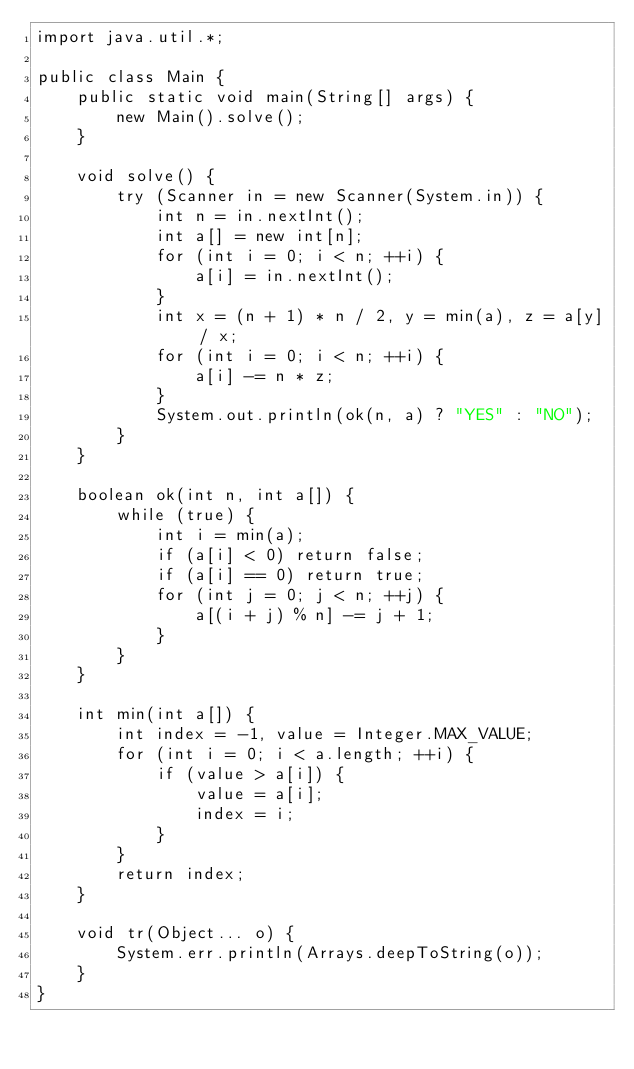<code> <loc_0><loc_0><loc_500><loc_500><_Java_>import java.util.*;

public class Main {
    public static void main(String[] args) {
        new Main().solve();
    }

    void solve() {
        try (Scanner in = new Scanner(System.in)) {
            int n = in.nextInt();
            int a[] = new int[n];
            for (int i = 0; i < n; ++i) {
                a[i] = in.nextInt();
            }
            int x = (n + 1) * n / 2, y = min(a), z = a[y] / x;
            for (int i = 0; i < n; ++i) {
                a[i] -= n * z;
            }
            System.out.println(ok(n, a) ? "YES" : "NO");
        }
    }

    boolean ok(int n, int a[]) {
        while (true) {
            int i = min(a);
            if (a[i] < 0) return false;
            if (a[i] == 0) return true;
            for (int j = 0; j < n; ++j) {
                a[(i + j) % n] -= j + 1;
            }
        }
    }

    int min(int a[]) {
        int index = -1, value = Integer.MAX_VALUE;
        for (int i = 0; i < a.length; ++i) {
            if (value > a[i]) {
                value = a[i];
                index = i;
            }
        }
        return index;
    }

    void tr(Object... o) {
        System.err.println(Arrays.deepToString(o));
    }
}
</code> 